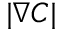<formula> <loc_0><loc_0><loc_500><loc_500>| \nabla C |</formula> 